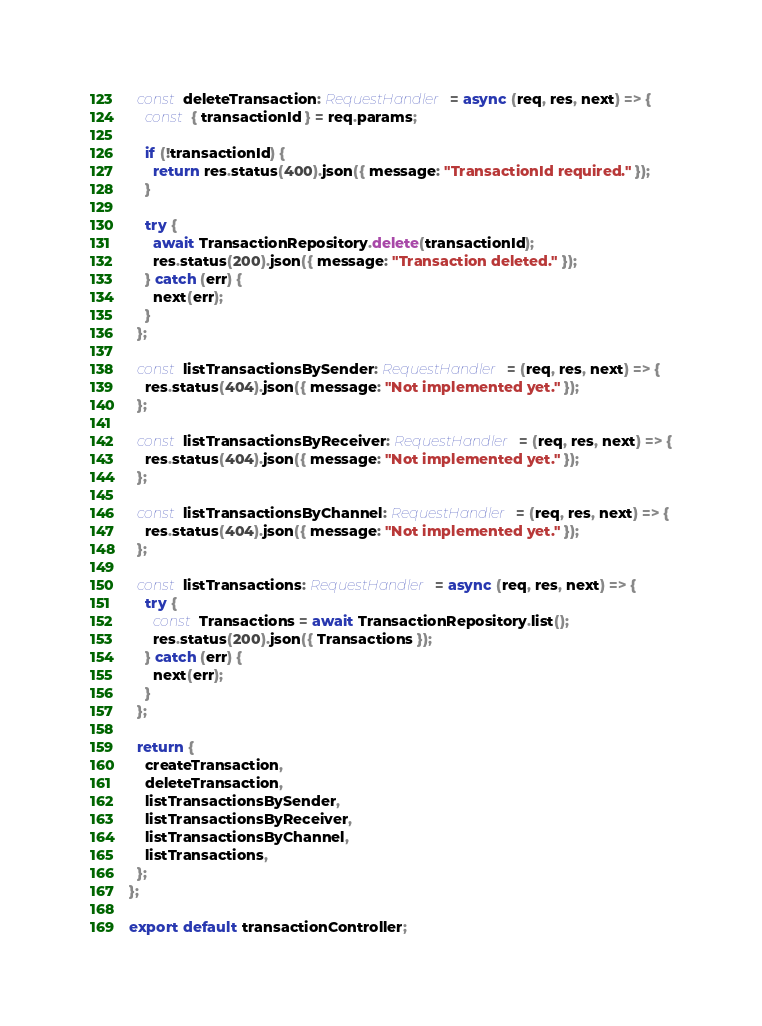<code> <loc_0><loc_0><loc_500><loc_500><_TypeScript_>
  const deleteTransaction: RequestHandler = async (req, res, next) => {
    const { transactionId } = req.params;

    if (!transactionId) {
      return res.status(400).json({ message: "TransactionId required." });
    }

    try {
      await TransactionRepository.delete(transactionId);
      res.status(200).json({ message: "Transaction deleted." });
    } catch (err) {
      next(err);
    }
  };

  const listTransactionsBySender: RequestHandler = (req, res, next) => {
    res.status(404).json({ message: "Not implemented yet." });
  };

  const listTransactionsByReceiver: RequestHandler = (req, res, next) => {
    res.status(404).json({ message: "Not implemented yet." });
  };

  const listTransactionsByChannel: RequestHandler = (req, res, next) => {
    res.status(404).json({ message: "Not implemented yet." });
  };

  const listTransactions: RequestHandler = async (req, res, next) => {
    try {
      const Transactions = await TransactionRepository.list();
      res.status(200).json({ Transactions });
    } catch (err) {
      next(err);
    }
  };

  return {
    createTransaction,
    deleteTransaction,
    listTransactionsBySender,
    listTransactionsByReceiver,
    listTransactionsByChannel,
    listTransactions,
  };
};

export default transactionController;
</code> 